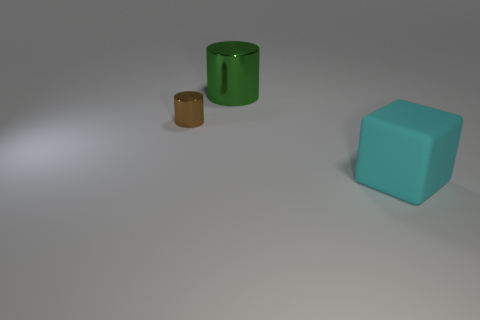Is the small cylinder the same color as the big rubber block?
Ensure brevity in your answer.  No. What shape is the object that is in front of the object to the left of the green metal cylinder to the right of the tiny shiny thing?
Ensure brevity in your answer.  Cube. How many objects are either large cylinders behind the brown cylinder or things that are on the right side of the tiny brown cylinder?
Offer a terse response. 2. There is a cylinder to the left of the big object that is left of the large rubber object; what is its size?
Give a very brief answer. Small. There is a cylinder to the left of the large green metallic object; does it have the same color as the matte object?
Provide a short and direct response. No. Are there any small brown objects that have the same shape as the large shiny thing?
Offer a terse response. Yes. The cylinder that is the same size as the cyan thing is what color?
Your answer should be compact. Green. There is a metallic thing behind the tiny brown cylinder; what is its size?
Ensure brevity in your answer.  Large. Are there any small cylinders that are in front of the cyan cube that is right of the green cylinder?
Offer a terse response. No. Do the large thing on the left side of the cyan matte block and the tiny brown cylinder have the same material?
Keep it short and to the point. Yes. 